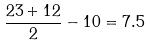Convert formula to latex. <formula><loc_0><loc_0><loc_500><loc_500>\frac { 2 3 + 1 2 } { 2 } - 1 0 = 7 . 5</formula> 